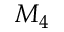<formula> <loc_0><loc_0><loc_500><loc_500>M _ { 4 }</formula> 